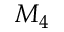<formula> <loc_0><loc_0><loc_500><loc_500>M _ { 4 }</formula> 